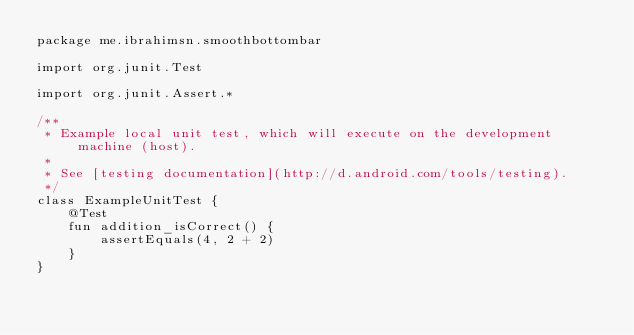Convert code to text. <code><loc_0><loc_0><loc_500><loc_500><_Kotlin_>package me.ibrahimsn.smoothbottombar

import org.junit.Test

import org.junit.Assert.*

/**
 * Example local unit test, which will execute on the development machine (host).
 *
 * See [testing documentation](http://d.android.com/tools/testing).
 */
class ExampleUnitTest {
    @Test
    fun addition_isCorrect() {
        assertEquals(4, 2 + 2)
    }
}
</code> 